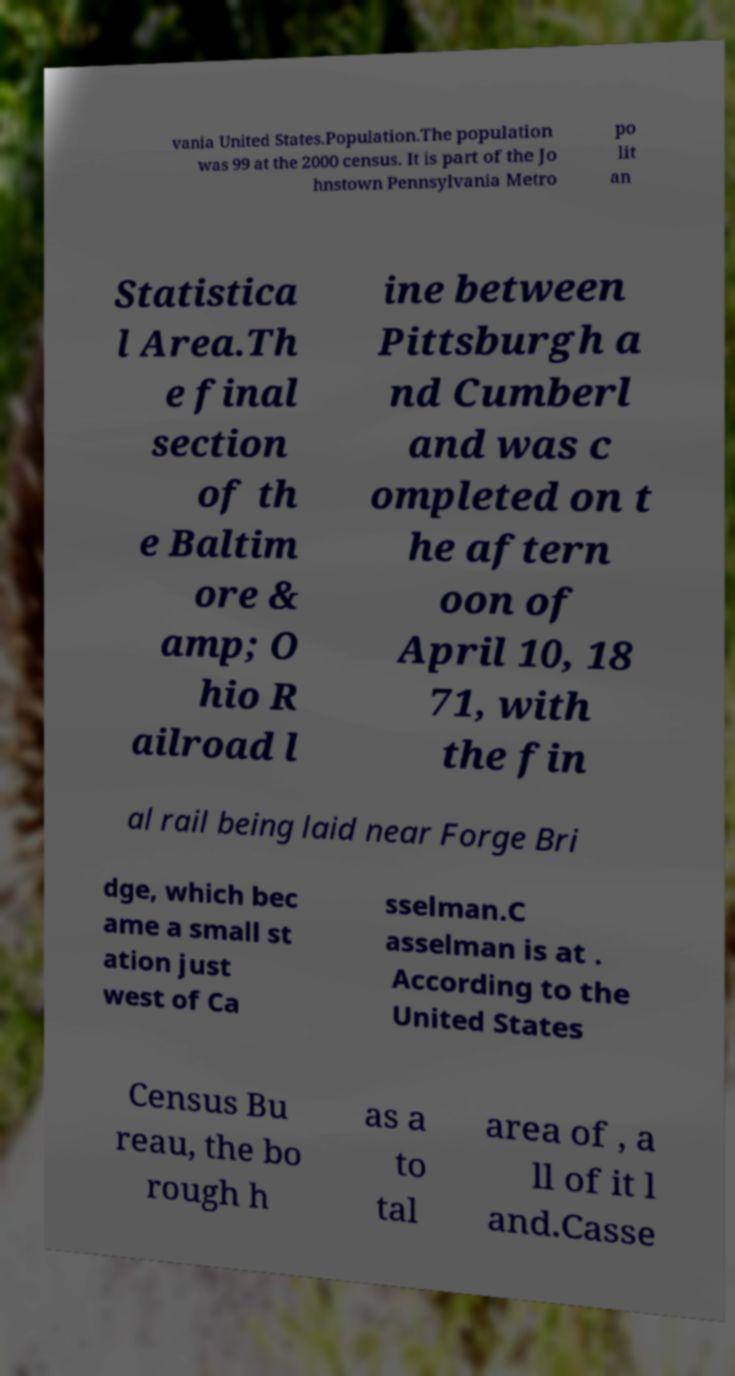What messages or text are displayed in this image? I need them in a readable, typed format. vania United States.Population.The population was 99 at the 2000 census. It is part of the Jo hnstown Pennsylvania Metro po lit an Statistica l Area.Th e final section of th e Baltim ore & amp; O hio R ailroad l ine between Pittsburgh a nd Cumberl and was c ompleted on t he aftern oon of April 10, 18 71, with the fin al rail being laid near Forge Bri dge, which bec ame a small st ation just west of Ca sselman.C asselman is at . According to the United States Census Bu reau, the bo rough h as a to tal area of , a ll of it l and.Casse 